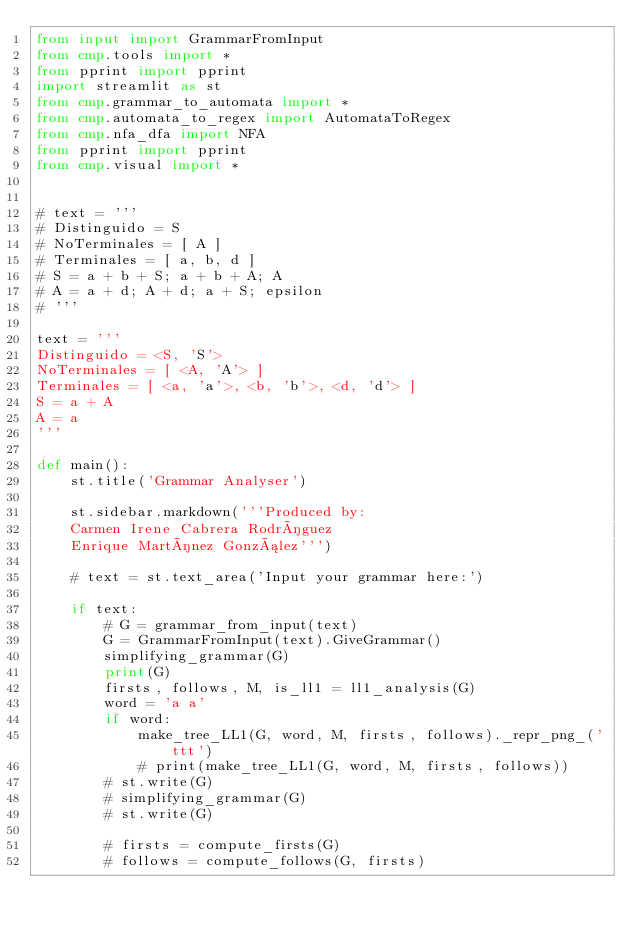Convert code to text. <code><loc_0><loc_0><loc_500><loc_500><_Python_>from input import GrammarFromInput
from cmp.tools import *
from pprint import pprint
import streamlit as st
from cmp.grammar_to_automata import *
from cmp.automata_to_regex import AutomataToRegex
from cmp.nfa_dfa import NFA
from pprint import pprint
from cmp.visual import *


# text = '''
# Distinguido = S
# NoTerminales = [ A ]
# Terminales = [ a, b, d ]
# S = a + b + S; a + b + A; A
# A = a + d; A + d; a + S; epsilon
# '''

text = '''
Distinguido = <S, 'S'>
NoTerminales = [ <A, 'A'> ]
Terminales = [ <a, 'a'>, <b, 'b'>, <d, 'd'> ]
S = a + A
A = a
'''

def main():
    st.title('Grammar Analyser')

    st.sidebar.markdown('''Produced by:  
    Carmen Irene Cabrera Rodríguez  
    Enrique Martínez González''')

    # text = st.text_area('Input your grammar here:')

    if text:
        # G = grammar_from_input(text)
        G = GrammarFromInput(text).GiveGrammar()
        simplifying_grammar(G)
        print(G)
        firsts, follows, M, is_ll1 = ll1_analysis(G)
        word = 'a a'
        if word:
            make_tree_LL1(G, word, M, firsts, follows)._repr_png_('ttt')
            # print(make_tree_LL1(G, word, M, firsts, follows))
        # st.write(G)
        # simplifying_grammar(G)
        # st.write(G)

        # firsts = compute_firsts(G)
        # follows = compute_follows(G, firsts)</code> 